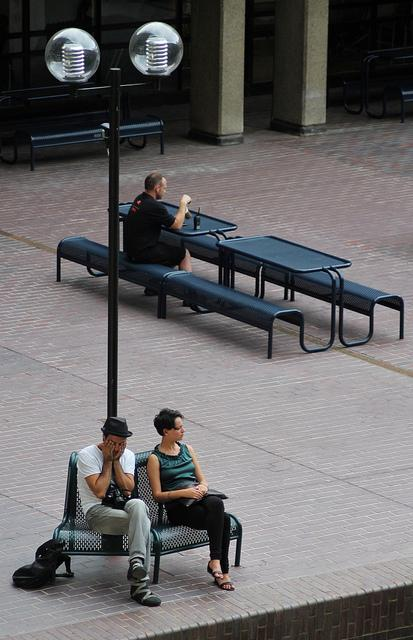What is the man at the table doing? eating 